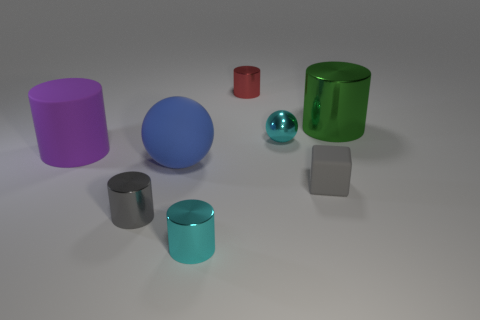Subtract all shiny cylinders. How many cylinders are left? 1 Subtract 1 cylinders. How many cylinders are left? 4 Subtract all purple cylinders. How many cylinders are left? 4 Add 1 cyan cylinders. How many objects exist? 9 Subtract all blue cylinders. Subtract all red cubes. How many cylinders are left? 5 Subtract all cubes. How many objects are left? 7 Subtract all gray cylinders. Subtract all purple objects. How many objects are left? 6 Add 1 large purple things. How many large purple things are left? 2 Add 3 large matte cylinders. How many large matte cylinders exist? 4 Subtract 0 gray spheres. How many objects are left? 8 